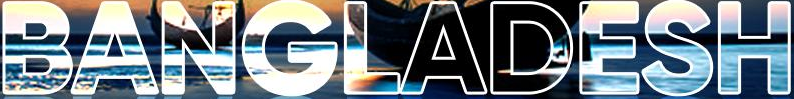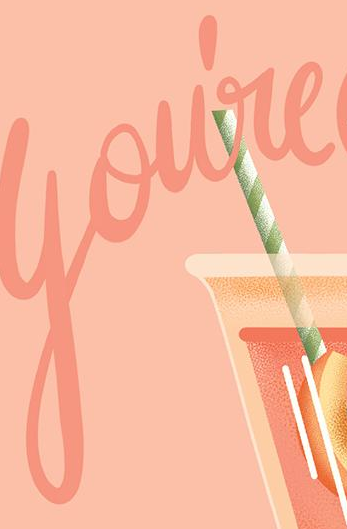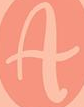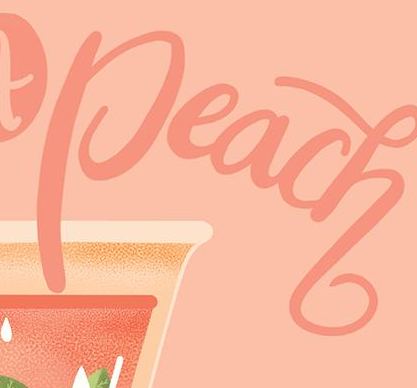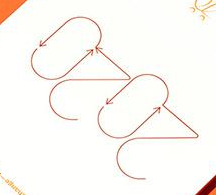What text appears in these images from left to right, separated by a semicolon? BANGLADESH; You're; A; Peach; 2020 